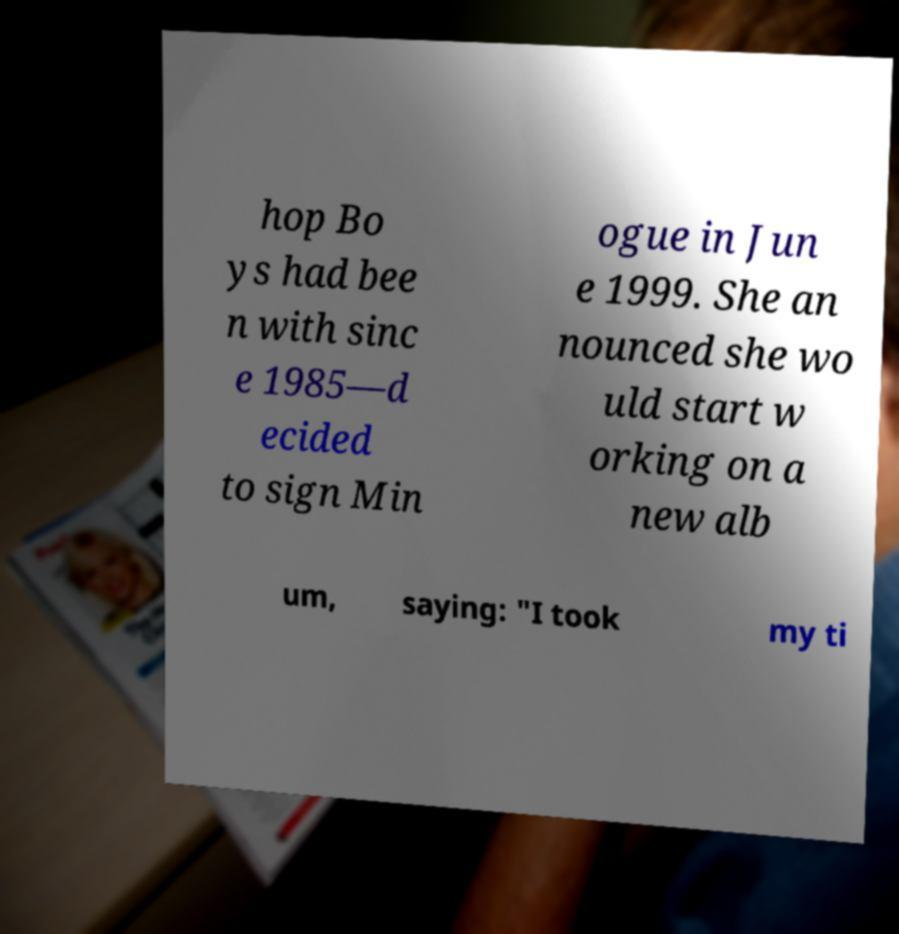Please read and relay the text visible in this image. What does it say? hop Bo ys had bee n with sinc e 1985—d ecided to sign Min ogue in Jun e 1999. She an nounced she wo uld start w orking on a new alb um, saying: "I took my ti 